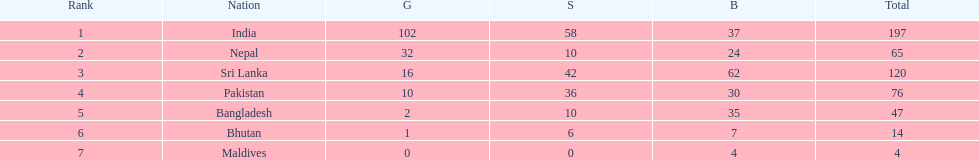What is the difference in total number of medals between india and nepal? 132. 